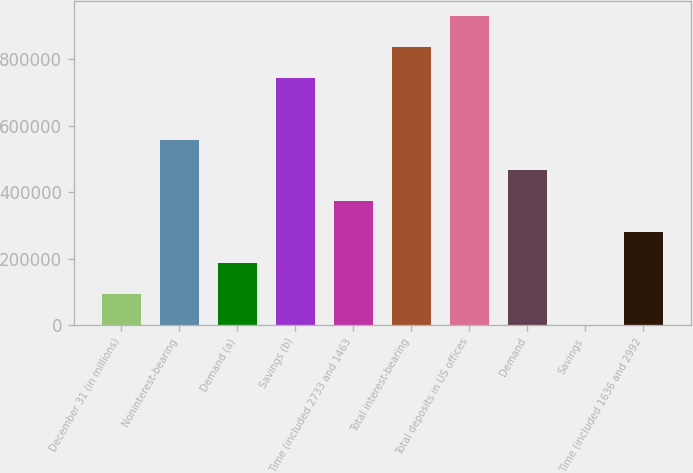Convert chart. <chart><loc_0><loc_0><loc_500><loc_500><bar_chart><fcel>December 31 (in millions)<fcel>Noninterest-bearing<fcel>Demand (a)<fcel>Savings (b)<fcel>Time (included 2733 and 1463<fcel>Total interest-bearing<fcel>Total deposits in US offices<fcel>Demand<fcel>Savings<fcel>Time (included 1636 and 2992<nl><fcel>93583.2<fcel>558464<fcel>186559<fcel>744417<fcel>372512<fcel>837393<fcel>930369<fcel>465488<fcel>607<fcel>279536<nl></chart> 